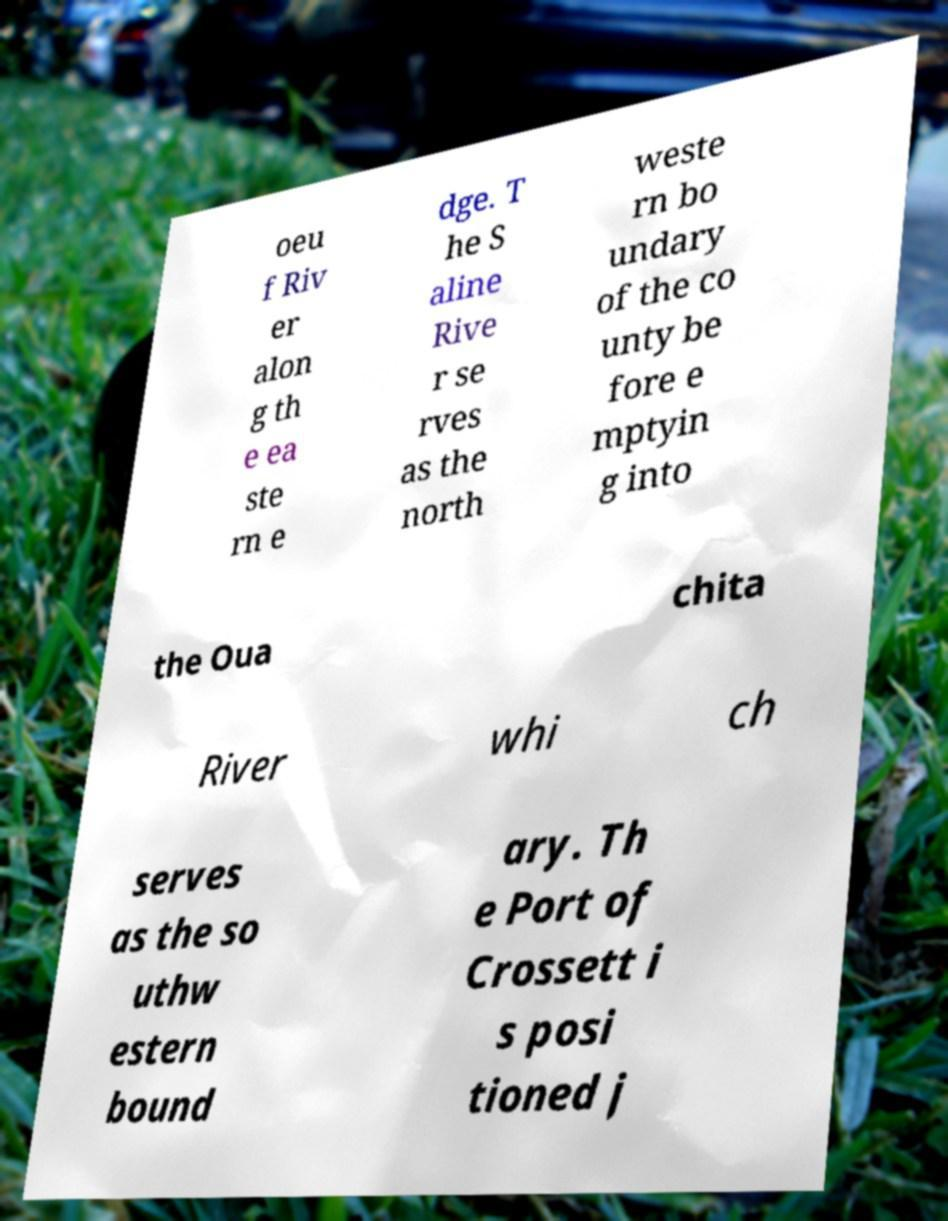Can you read and provide the text displayed in the image?This photo seems to have some interesting text. Can you extract and type it out for me? oeu f Riv er alon g th e ea ste rn e dge. T he S aline Rive r se rves as the north weste rn bo undary of the co unty be fore e mptyin g into the Oua chita River whi ch serves as the so uthw estern bound ary. Th e Port of Crossett i s posi tioned j 